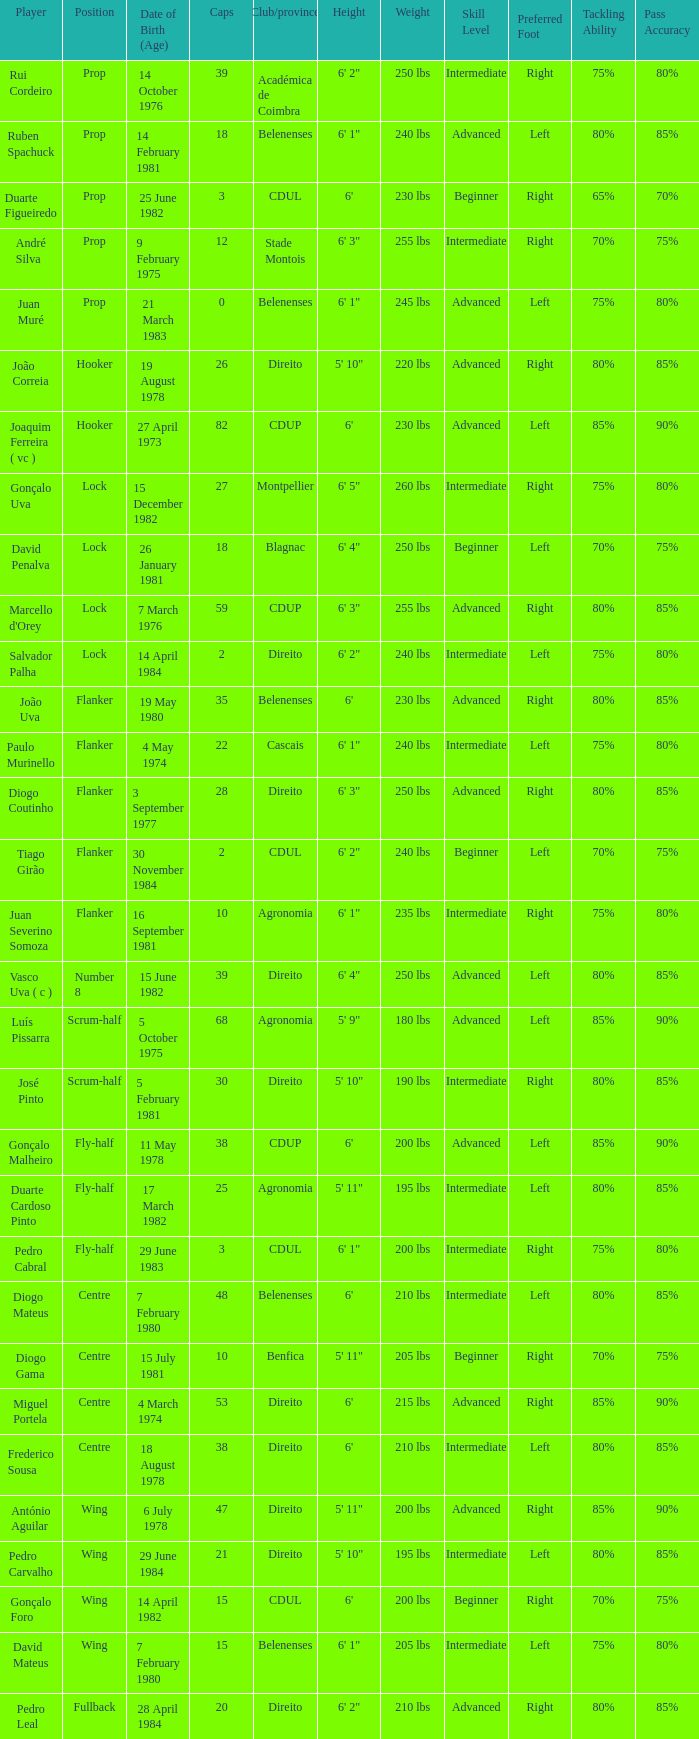Which player has a Club/province of direito, less than 21 caps, and a Position of lock? Salvador Palha. 